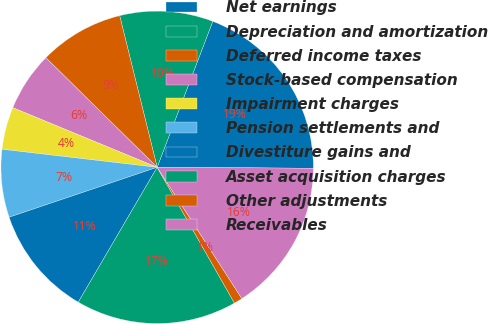<chart> <loc_0><loc_0><loc_500><loc_500><pie_chart><fcel>Net earnings<fcel>Depreciation and amortization<fcel>Deferred income taxes<fcel>Stock-based compensation<fcel>Impairment charges<fcel>Pension settlements and<fcel>Divestiture gains and<fcel>Asset acquisition charges<fcel>Other adjustments<fcel>Receivables<nl><fcel>19.3%<fcel>9.65%<fcel>8.77%<fcel>6.14%<fcel>4.39%<fcel>7.02%<fcel>11.4%<fcel>16.66%<fcel>0.88%<fcel>15.79%<nl></chart> 